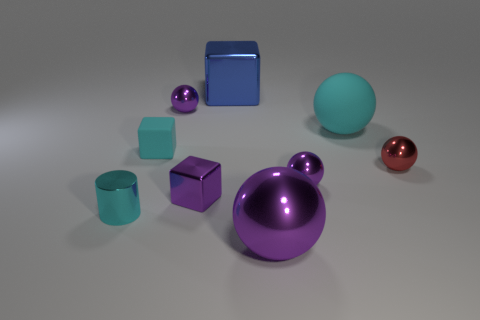What material is the small cyan thing behind the tiny purple metal object on the right side of the big shiny block?
Keep it short and to the point. Rubber. What number of objects are either gray rubber balls or shiny blocks that are in front of the big blue metallic cube?
Your answer should be compact. 1. There is a cyan cylinder that is made of the same material as the big purple ball; what is its size?
Offer a very short reply. Small. Are there more tiny spheres in front of the tiny red metal ball than big brown blocks?
Give a very brief answer. Yes. What size is the purple shiny sphere that is right of the big metallic block and behind the purple metal block?
Offer a very short reply. Small. There is a big purple thing that is the same shape as the red metallic object; what is it made of?
Offer a terse response. Metal. Does the purple shiny thing behind the red sphere have the same size as the small red metallic object?
Provide a short and direct response. Yes. The small metal object that is to the left of the purple block and in front of the large matte object is what color?
Offer a terse response. Cyan. What number of tiny purple things are right of the small sphere behind the matte ball?
Provide a succinct answer. 2. Is the shape of the big blue object the same as the tiny rubber thing?
Make the answer very short. Yes. 